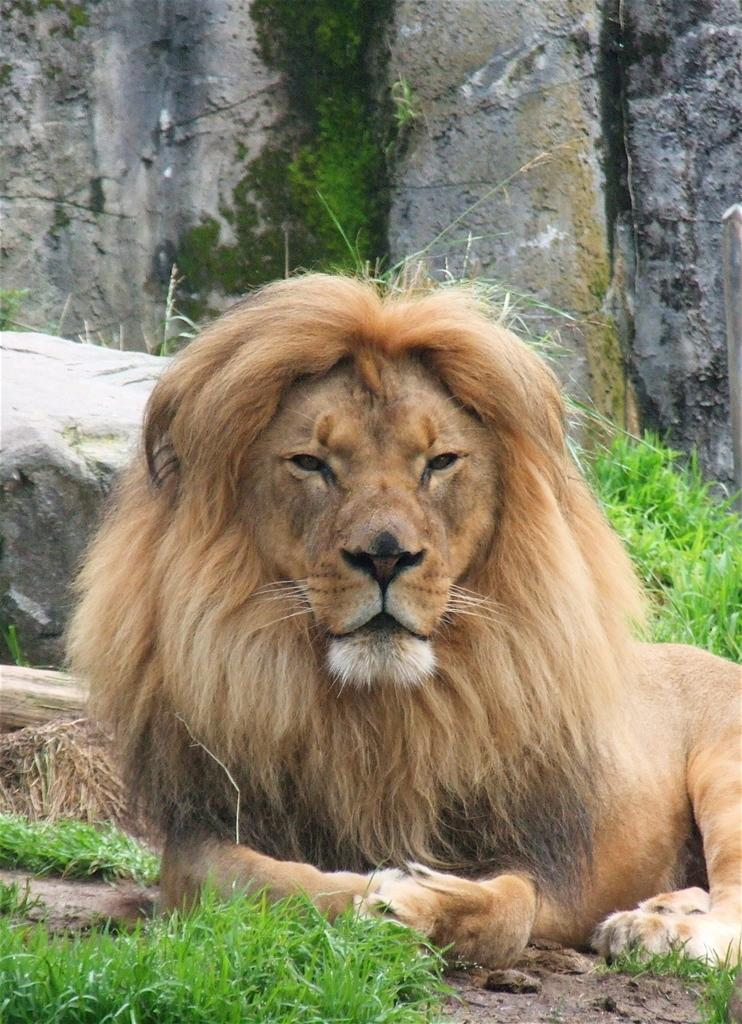What animal is the main subject of the image? There is a lion in the image. Can you describe the color of the lion? The lion is brown, cream, and black in color. What position is the lion in? The lion is laying on the ground. What type of vegetation is present on the ground? There is grass on the ground. What other natural elements can be seen in the image? There are rocks behind the lion. Where is the locket hanging in the image? There is no locket present in the image; it features a lion laying on the ground. What type of hall can be seen in the background of the image? There is no hall present in the image; it features a lion laying on the ground with grass and rocks in the background. 